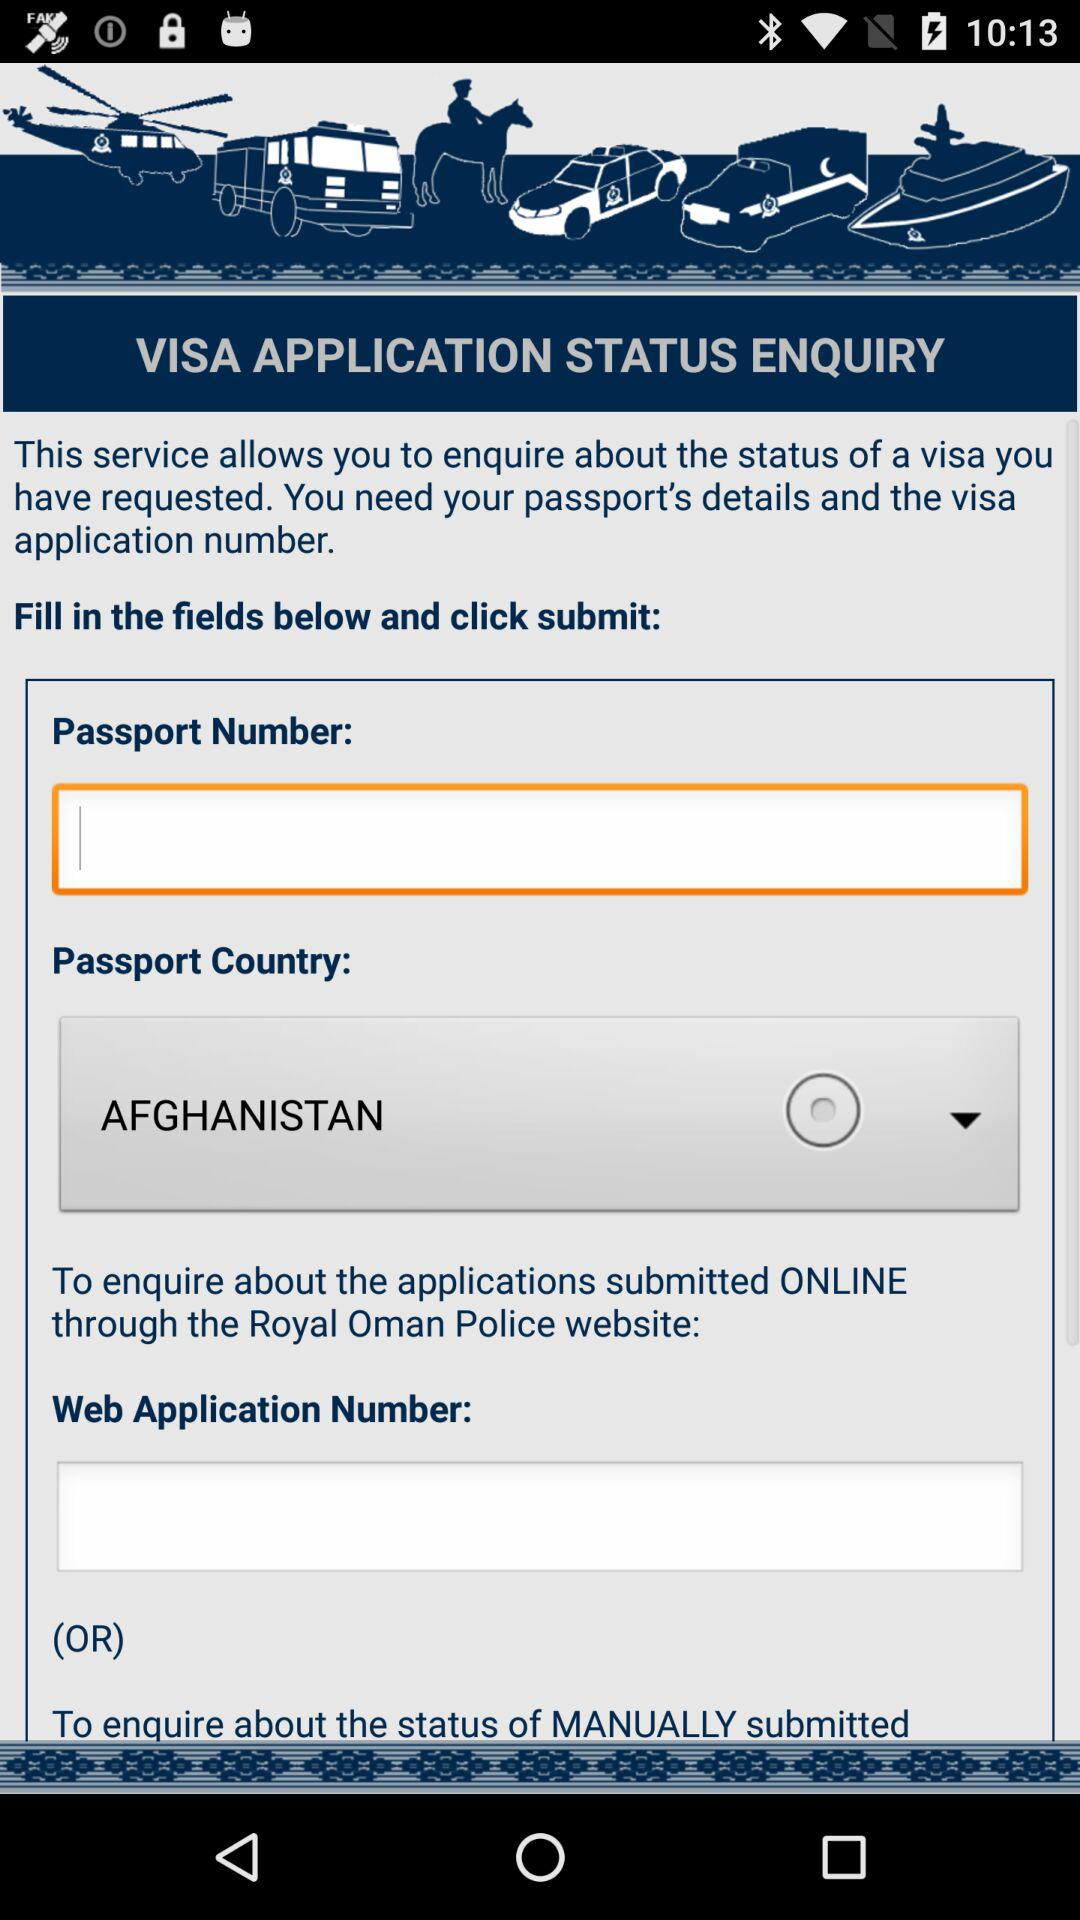What is the selected "Passport Country"? The selected "Passport Country" is Afghanistan. 